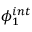Convert formula to latex. <formula><loc_0><loc_0><loc_500><loc_500>\phi _ { 1 } ^ { i n t }</formula> 